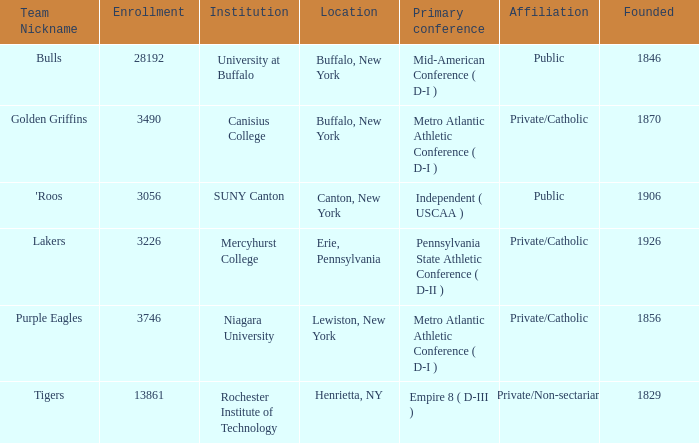What was the enrollment of the school founded in 1846? 28192.0. 